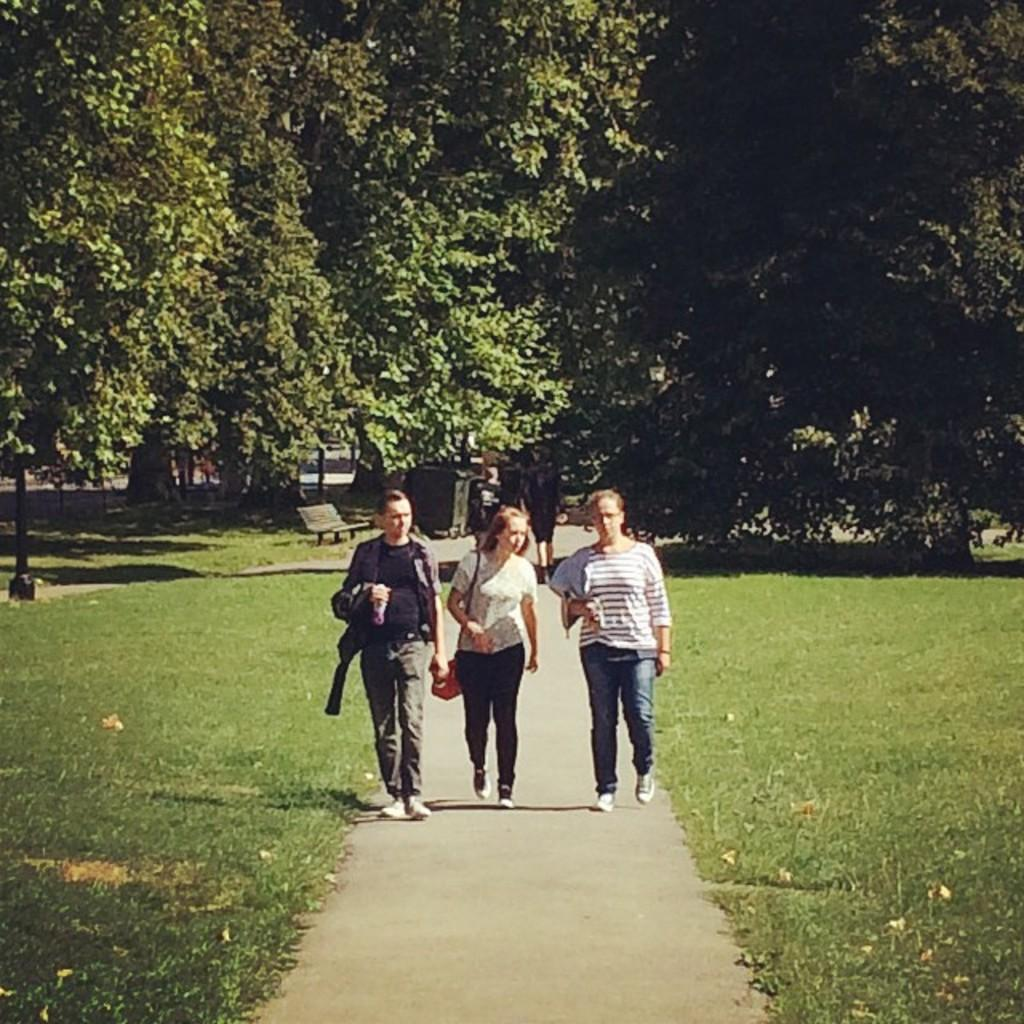How many people are walking in the image? There are three persons walking in the image. What can be seen in the background of the image? There is a bench and trees with green color in the background of the image. What type of frog can be seen sitting on the bench in the image? There is no frog present in the image; it only features three persons walking and a bench in the background. 